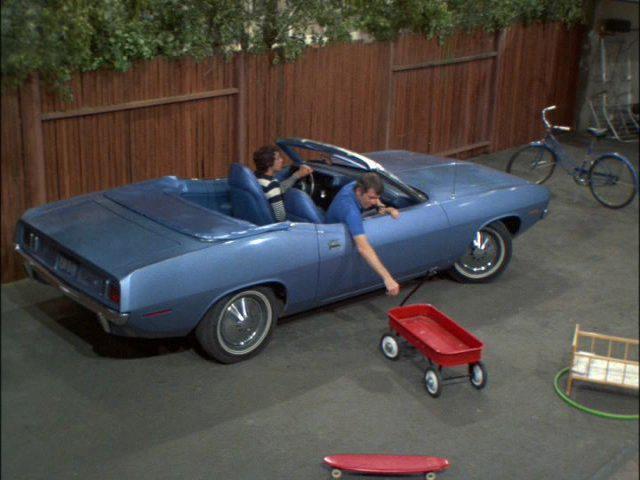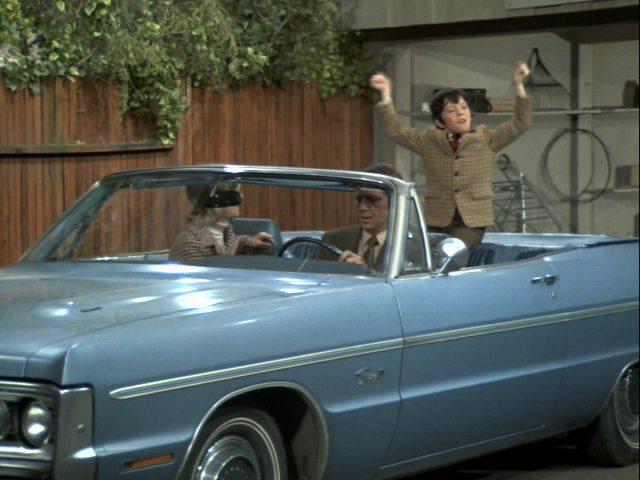The first image is the image on the left, the second image is the image on the right. For the images displayed, is the sentence "Two people are sitting in a car in at least one of the images." factually correct? Answer yes or no. Yes. The first image is the image on the left, the second image is the image on the right. For the images displayed, is the sentence "Both images have a brown wooden fence in the background." factually correct? Answer yes or no. Yes. 